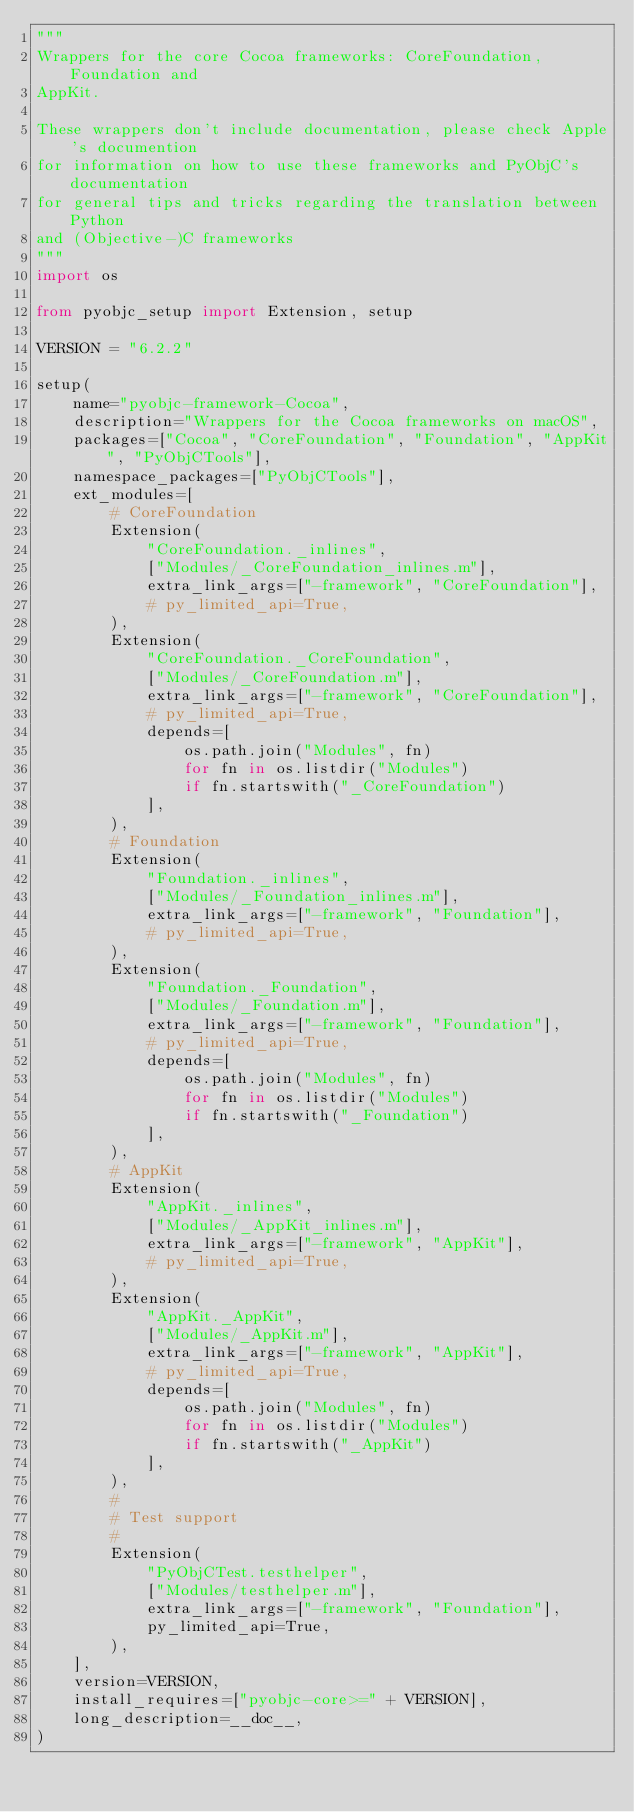Convert code to text. <code><loc_0><loc_0><loc_500><loc_500><_Python_>"""
Wrappers for the core Cocoa frameworks: CoreFoundation, Foundation and
AppKit.

These wrappers don't include documentation, please check Apple's documention
for information on how to use these frameworks and PyObjC's documentation
for general tips and tricks regarding the translation between Python
and (Objective-)C frameworks
"""
import os

from pyobjc_setup import Extension, setup

VERSION = "6.2.2"

setup(
    name="pyobjc-framework-Cocoa",
    description="Wrappers for the Cocoa frameworks on macOS",
    packages=["Cocoa", "CoreFoundation", "Foundation", "AppKit", "PyObjCTools"],
    namespace_packages=["PyObjCTools"],
    ext_modules=[
        # CoreFoundation
        Extension(
            "CoreFoundation._inlines",
            ["Modules/_CoreFoundation_inlines.m"],
            extra_link_args=["-framework", "CoreFoundation"],
            # py_limited_api=True,
        ),
        Extension(
            "CoreFoundation._CoreFoundation",
            ["Modules/_CoreFoundation.m"],
            extra_link_args=["-framework", "CoreFoundation"],
            # py_limited_api=True,
            depends=[
                os.path.join("Modules", fn)
                for fn in os.listdir("Modules")
                if fn.startswith("_CoreFoundation")
            ],
        ),
        # Foundation
        Extension(
            "Foundation._inlines",
            ["Modules/_Foundation_inlines.m"],
            extra_link_args=["-framework", "Foundation"],
            # py_limited_api=True,
        ),
        Extension(
            "Foundation._Foundation",
            ["Modules/_Foundation.m"],
            extra_link_args=["-framework", "Foundation"],
            # py_limited_api=True,
            depends=[
                os.path.join("Modules", fn)
                for fn in os.listdir("Modules")
                if fn.startswith("_Foundation")
            ],
        ),
        # AppKit
        Extension(
            "AppKit._inlines",
            ["Modules/_AppKit_inlines.m"],
            extra_link_args=["-framework", "AppKit"],
            # py_limited_api=True,
        ),
        Extension(
            "AppKit._AppKit",
            ["Modules/_AppKit.m"],
            extra_link_args=["-framework", "AppKit"],
            # py_limited_api=True,
            depends=[
                os.path.join("Modules", fn)
                for fn in os.listdir("Modules")
                if fn.startswith("_AppKit")
            ],
        ),
        #
        # Test support
        #
        Extension(
            "PyObjCTest.testhelper",
            ["Modules/testhelper.m"],
            extra_link_args=["-framework", "Foundation"],
            py_limited_api=True,
        ),
    ],
    version=VERSION,
    install_requires=["pyobjc-core>=" + VERSION],
    long_description=__doc__,
)
</code> 